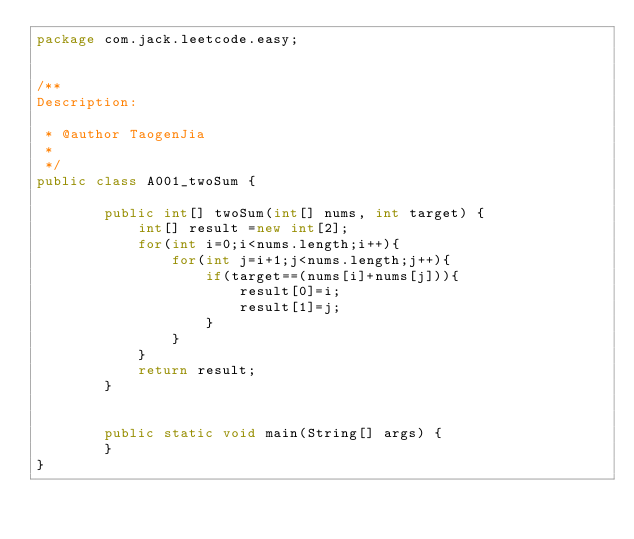<code> <loc_0><loc_0><loc_500><loc_500><_Java_>package com.jack.leetcode.easy;


/**
Description:
 
 * @author TaogenJia
 *
 */
public class A001_twoSum {

	    public int[] twoSum(int[] nums, int target) {
	        int[] result =new int[2];
	        for(int i=0;i<nums.length;i++){
	            for(int j=i+1;j<nums.length;j++){
	                if(target==(nums[i]+nums[j])){
	                    result[0]=i;
	                    result[1]=j;
	                }
	            }
	        }
			return result;
	    }
	    
	    
	    public static void main(String[] args) {
		}
}
</code> 